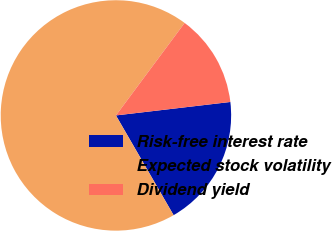<chart> <loc_0><loc_0><loc_500><loc_500><pie_chart><fcel>Risk-free interest rate<fcel>Expected stock volatility<fcel>Dividend yield<nl><fcel>18.52%<fcel>68.51%<fcel>12.97%<nl></chart> 